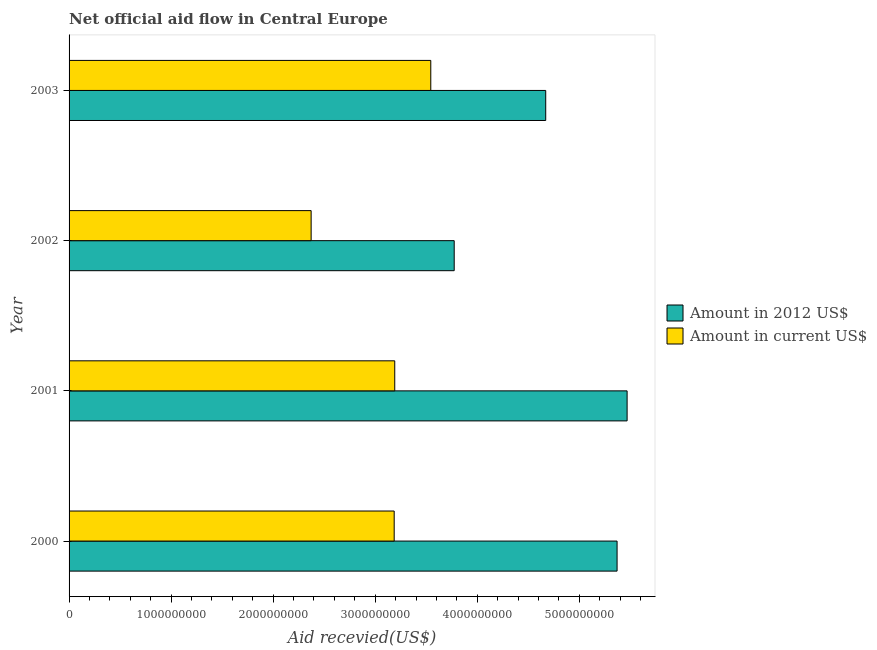How many different coloured bars are there?
Your answer should be very brief. 2. How many groups of bars are there?
Offer a terse response. 4. Are the number of bars per tick equal to the number of legend labels?
Offer a very short reply. Yes. Are the number of bars on each tick of the Y-axis equal?
Give a very brief answer. Yes. How many bars are there on the 1st tick from the top?
Make the answer very short. 2. What is the label of the 2nd group of bars from the top?
Give a very brief answer. 2002. In how many cases, is the number of bars for a given year not equal to the number of legend labels?
Your response must be concise. 0. What is the amount of aid received(expressed in 2012 us$) in 2003?
Provide a succinct answer. 4.67e+09. Across all years, what is the maximum amount of aid received(expressed in 2012 us$)?
Give a very brief answer. 5.47e+09. Across all years, what is the minimum amount of aid received(expressed in 2012 us$)?
Your response must be concise. 3.77e+09. In which year was the amount of aid received(expressed in 2012 us$) minimum?
Provide a succinct answer. 2002. What is the total amount of aid received(expressed in 2012 us$) in the graph?
Offer a terse response. 1.93e+1. What is the difference between the amount of aid received(expressed in us$) in 2000 and that in 2003?
Provide a short and direct response. -3.59e+08. What is the difference between the amount of aid received(expressed in 2012 us$) in 2003 and the amount of aid received(expressed in us$) in 2001?
Give a very brief answer. 1.48e+09. What is the average amount of aid received(expressed in 2012 us$) per year?
Give a very brief answer. 4.82e+09. In the year 2001, what is the difference between the amount of aid received(expressed in us$) and amount of aid received(expressed in 2012 us$)?
Give a very brief answer. -2.28e+09. In how many years, is the amount of aid received(expressed in 2012 us$) greater than 1600000000 US$?
Provide a succinct answer. 4. What is the ratio of the amount of aid received(expressed in 2012 us$) in 2000 to that in 2001?
Give a very brief answer. 0.98. Is the amount of aid received(expressed in 2012 us$) in 2000 less than that in 2002?
Give a very brief answer. No. Is the difference between the amount of aid received(expressed in 2012 us$) in 2001 and 2002 greater than the difference between the amount of aid received(expressed in us$) in 2001 and 2002?
Your response must be concise. Yes. What is the difference between the highest and the second highest amount of aid received(expressed in us$)?
Offer a very short reply. 3.53e+08. What is the difference between the highest and the lowest amount of aid received(expressed in 2012 us$)?
Offer a terse response. 1.69e+09. Is the sum of the amount of aid received(expressed in us$) in 2001 and 2003 greater than the maximum amount of aid received(expressed in 2012 us$) across all years?
Offer a terse response. Yes. What does the 2nd bar from the top in 2002 represents?
Your answer should be compact. Amount in 2012 US$. What does the 2nd bar from the bottom in 2000 represents?
Offer a very short reply. Amount in current US$. What is the difference between two consecutive major ticks on the X-axis?
Give a very brief answer. 1.00e+09. Are the values on the major ticks of X-axis written in scientific E-notation?
Your response must be concise. No. Does the graph contain any zero values?
Your response must be concise. No. Does the graph contain grids?
Make the answer very short. No. Where does the legend appear in the graph?
Your response must be concise. Center right. How many legend labels are there?
Offer a very short reply. 2. What is the title of the graph?
Give a very brief answer. Net official aid flow in Central Europe. What is the label or title of the X-axis?
Provide a succinct answer. Aid recevied(US$). What is the label or title of the Y-axis?
Provide a short and direct response. Year. What is the Aid recevied(US$) of Amount in 2012 US$ in 2000?
Give a very brief answer. 5.37e+09. What is the Aid recevied(US$) in Amount in current US$ in 2000?
Ensure brevity in your answer.  3.19e+09. What is the Aid recevied(US$) in Amount in 2012 US$ in 2001?
Your answer should be very brief. 5.47e+09. What is the Aid recevied(US$) in Amount in current US$ in 2001?
Keep it short and to the point. 3.19e+09. What is the Aid recevied(US$) in Amount in 2012 US$ in 2002?
Provide a short and direct response. 3.77e+09. What is the Aid recevied(US$) in Amount in current US$ in 2002?
Provide a succinct answer. 2.37e+09. What is the Aid recevied(US$) of Amount in 2012 US$ in 2003?
Make the answer very short. 4.67e+09. What is the Aid recevied(US$) of Amount in current US$ in 2003?
Give a very brief answer. 3.54e+09. Across all years, what is the maximum Aid recevied(US$) of Amount in 2012 US$?
Give a very brief answer. 5.47e+09. Across all years, what is the maximum Aid recevied(US$) in Amount in current US$?
Provide a short and direct response. 3.54e+09. Across all years, what is the minimum Aid recevied(US$) of Amount in 2012 US$?
Your answer should be very brief. 3.77e+09. Across all years, what is the minimum Aid recevied(US$) of Amount in current US$?
Your answer should be compact. 2.37e+09. What is the total Aid recevied(US$) of Amount in 2012 US$ in the graph?
Your response must be concise. 1.93e+1. What is the total Aid recevied(US$) of Amount in current US$ in the graph?
Your answer should be compact. 1.23e+1. What is the difference between the Aid recevied(US$) in Amount in 2012 US$ in 2000 and that in 2001?
Offer a terse response. -9.83e+07. What is the difference between the Aid recevied(US$) in Amount in current US$ in 2000 and that in 2001?
Make the answer very short. -5.47e+06. What is the difference between the Aid recevied(US$) of Amount in 2012 US$ in 2000 and that in 2002?
Offer a terse response. 1.60e+09. What is the difference between the Aid recevied(US$) of Amount in current US$ in 2000 and that in 2002?
Ensure brevity in your answer.  8.14e+08. What is the difference between the Aid recevied(US$) in Amount in 2012 US$ in 2000 and that in 2003?
Ensure brevity in your answer.  6.99e+08. What is the difference between the Aid recevied(US$) of Amount in current US$ in 2000 and that in 2003?
Your response must be concise. -3.59e+08. What is the difference between the Aid recevied(US$) of Amount in 2012 US$ in 2001 and that in 2002?
Provide a succinct answer. 1.69e+09. What is the difference between the Aid recevied(US$) in Amount in current US$ in 2001 and that in 2002?
Provide a short and direct response. 8.19e+08. What is the difference between the Aid recevied(US$) of Amount in 2012 US$ in 2001 and that in 2003?
Keep it short and to the point. 7.98e+08. What is the difference between the Aid recevied(US$) in Amount in current US$ in 2001 and that in 2003?
Offer a terse response. -3.53e+08. What is the difference between the Aid recevied(US$) in Amount in 2012 US$ in 2002 and that in 2003?
Ensure brevity in your answer.  -8.97e+08. What is the difference between the Aid recevied(US$) in Amount in current US$ in 2002 and that in 2003?
Give a very brief answer. -1.17e+09. What is the difference between the Aid recevied(US$) of Amount in 2012 US$ in 2000 and the Aid recevied(US$) of Amount in current US$ in 2001?
Your answer should be compact. 2.18e+09. What is the difference between the Aid recevied(US$) in Amount in 2012 US$ in 2000 and the Aid recevied(US$) in Amount in current US$ in 2002?
Provide a succinct answer. 3.00e+09. What is the difference between the Aid recevied(US$) of Amount in 2012 US$ in 2000 and the Aid recevied(US$) of Amount in current US$ in 2003?
Give a very brief answer. 1.83e+09. What is the difference between the Aid recevied(US$) of Amount in 2012 US$ in 2001 and the Aid recevied(US$) of Amount in current US$ in 2002?
Your answer should be compact. 3.10e+09. What is the difference between the Aid recevied(US$) of Amount in 2012 US$ in 2001 and the Aid recevied(US$) of Amount in current US$ in 2003?
Offer a very short reply. 1.92e+09. What is the difference between the Aid recevied(US$) in Amount in 2012 US$ in 2002 and the Aid recevied(US$) in Amount in current US$ in 2003?
Provide a succinct answer. 2.29e+08. What is the average Aid recevied(US$) of Amount in 2012 US$ per year?
Offer a very short reply. 4.82e+09. What is the average Aid recevied(US$) in Amount in current US$ per year?
Your answer should be compact. 3.07e+09. In the year 2000, what is the difference between the Aid recevied(US$) of Amount in 2012 US$ and Aid recevied(US$) of Amount in current US$?
Ensure brevity in your answer.  2.18e+09. In the year 2001, what is the difference between the Aid recevied(US$) in Amount in 2012 US$ and Aid recevied(US$) in Amount in current US$?
Make the answer very short. 2.28e+09. In the year 2002, what is the difference between the Aid recevied(US$) in Amount in 2012 US$ and Aid recevied(US$) in Amount in current US$?
Provide a succinct answer. 1.40e+09. In the year 2003, what is the difference between the Aid recevied(US$) of Amount in 2012 US$ and Aid recevied(US$) of Amount in current US$?
Your answer should be compact. 1.13e+09. What is the ratio of the Aid recevied(US$) of Amount in current US$ in 2000 to that in 2001?
Your answer should be very brief. 1. What is the ratio of the Aid recevied(US$) of Amount in 2012 US$ in 2000 to that in 2002?
Ensure brevity in your answer.  1.42. What is the ratio of the Aid recevied(US$) in Amount in current US$ in 2000 to that in 2002?
Your answer should be very brief. 1.34. What is the ratio of the Aid recevied(US$) of Amount in 2012 US$ in 2000 to that in 2003?
Offer a terse response. 1.15. What is the ratio of the Aid recevied(US$) in Amount in current US$ in 2000 to that in 2003?
Offer a terse response. 0.9. What is the ratio of the Aid recevied(US$) of Amount in 2012 US$ in 2001 to that in 2002?
Offer a terse response. 1.45. What is the ratio of the Aid recevied(US$) of Amount in current US$ in 2001 to that in 2002?
Provide a succinct answer. 1.35. What is the ratio of the Aid recevied(US$) of Amount in 2012 US$ in 2001 to that in 2003?
Keep it short and to the point. 1.17. What is the ratio of the Aid recevied(US$) in Amount in current US$ in 2001 to that in 2003?
Offer a very short reply. 0.9. What is the ratio of the Aid recevied(US$) of Amount in 2012 US$ in 2002 to that in 2003?
Your response must be concise. 0.81. What is the ratio of the Aid recevied(US$) in Amount in current US$ in 2002 to that in 2003?
Keep it short and to the point. 0.67. What is the difference between the highest and the second highest Aid recevied(US$) in Amount in 2012 US$?
Offer a terse response. 9.83e+07. What is the difference between the highest and the second highest Aid recevied(US$) of Amount in current US$?
Give a very brief answer. 3.53e+08. What is the difference between the highest and the lowest Aid recevied(US$) of Amount in 2012 US$?
Make the answer very short. 1.69e+09. What is the difference between the highest and the lowest Aid recevied(US$) of Amount in current US$?
Provide a short and direct response. 1.17e+09. 